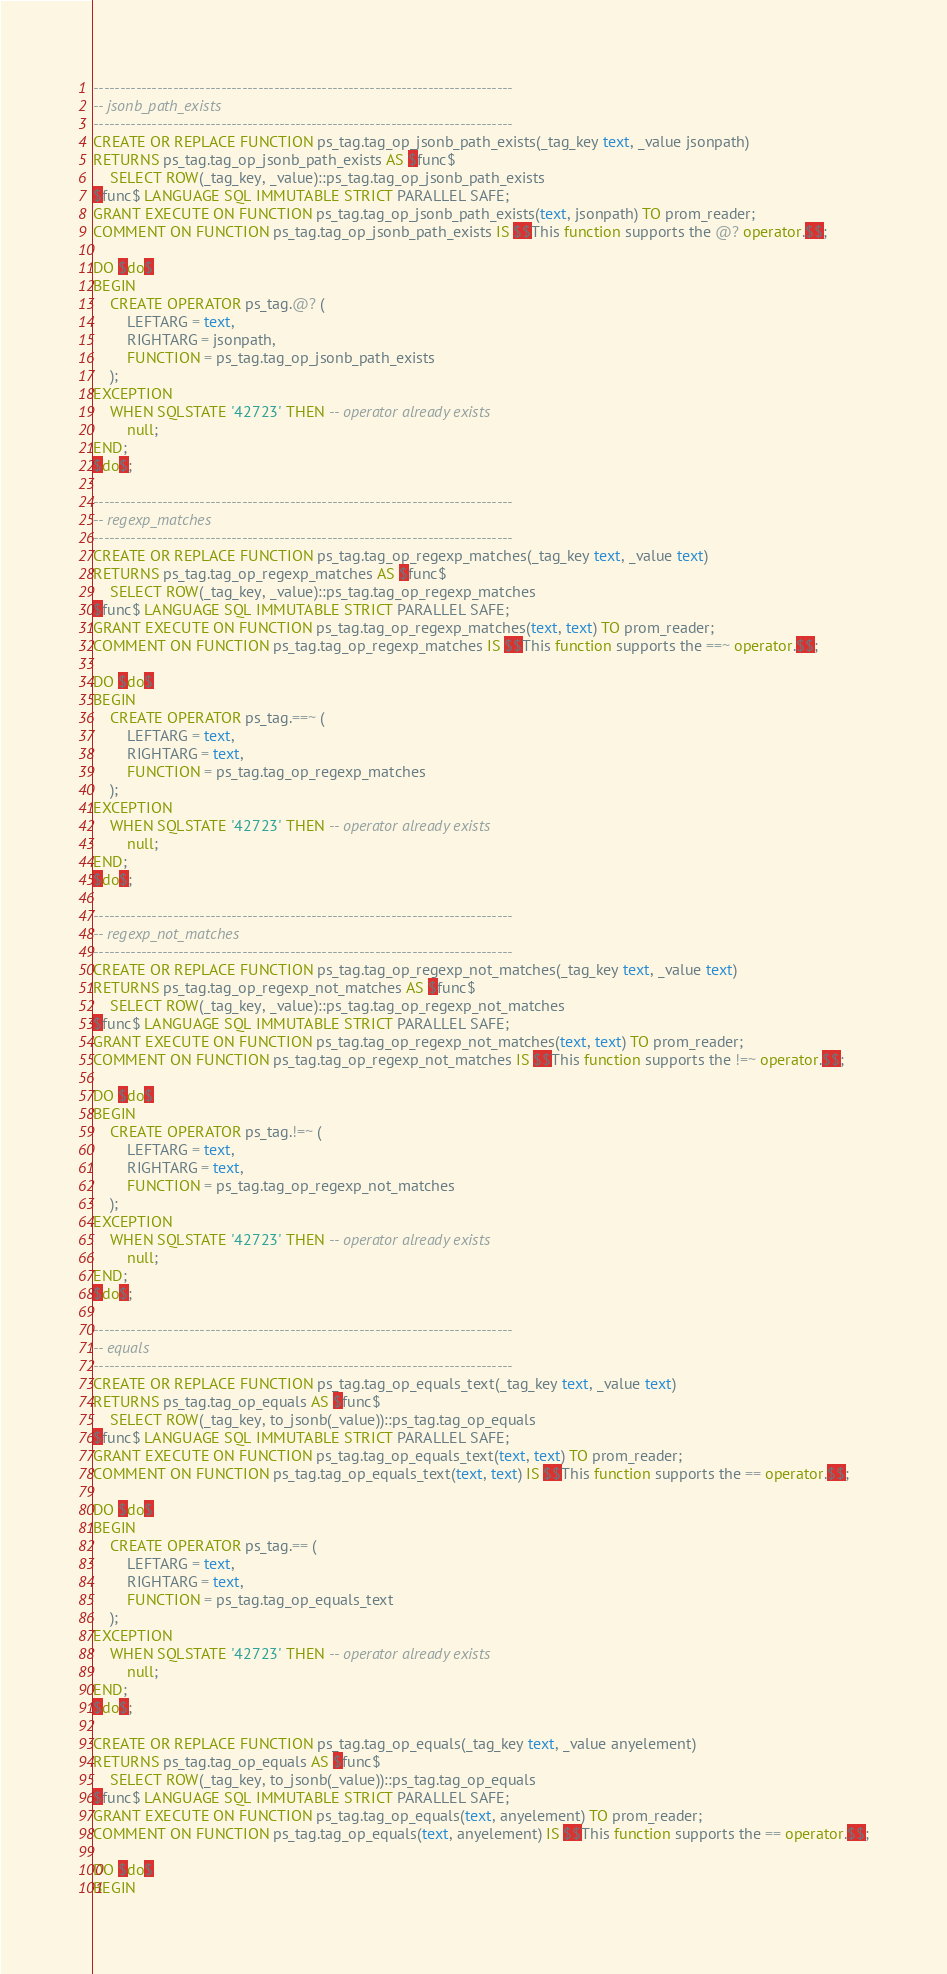Convert code to text. <code><loc_0><loc_0><loc_500><loc_500><_SQL_>-------------------------------------------------------------------------------
-- jsonb_path_exists
-------------------------------------------------------------------------------
CREATE OR REPLACE FUNCTION ps_tag.tag_op_jsonb_path_exists(_tag_key text, _value jsonpath)
RETURNS ps_tag.tag_op_jsonb_path_exists AS $func$
    SELECT ROW(_tag_key, _value)::ps_tag.tag_op_jsonb_path_exists
$func$ LANGUAGE SQL IMMUTABLE STRICT PARALLEL SAFE;
GRANT EXECUTE ON FUNCTION ps_tag.tag_op_jsonb_path_exists(text, jsonpath) TO prom_reader;
COMMENT ON FUNCTION ps_tag.tag_op_jsonb_path_exists IS $$This function supports the @? operator.$$;

DO $do$
BEGIN
    CREATE OPERATOR ps_tag.@? (
        LEFTARG = text,
        RIGHTARG = jsonpath,
        FUNCTION = ps_tag.tag_op_jsonb_path_exists
    );
EXCEPTION
    WHEN SQLSTATE '42723' THEN -- operator already exists
        null;
END;
$do$;

-------------------------------------------------------------------------------
-- regexp_matches
-------------------------------------------------------------------------------
CREATE OR REPLACE FUNCTION ps_tag.tag_op_regexp_matches(_tag_key text, _value text)
RETURNS ps_tag.tag_op_regexp_matches AS $func$
    SELECT ROW(_tag_key, _value)::ps_tag.tag_op_regexp_matches
$func$ LANGUAGE SQL IMMUTABLE STRICT PARALLEL SAFE;
GRANT EXECUTE ON FUNCTION ps_tag.tag_op_regexp_matches(text, text) TO prom_reader;
COMMENT ON FUNCTION ps_tag.tag_op_regexp_matches IS $$This function supports the ==~ operator.$$;

DO $do$
BEGIN
    CREATE OPERATOR ps_tag.==~ (
        LEFTARG = text,
        RIGHTARG = text,
        FUNCTION = ps_tag.tag_op_regexp_matches
    );
EXCEPTION
    WHEN SQLSTATE '42723' THEN -- operator already exists
        null;
END;
$do$;

-------------------------------------------------------------------------------
-- regexp_not_matches
-------------------------------------------------------------------------------
CREATE OR REPLACE FUNCTION ps_tag.tag_op_regexp_not_matches(_tag_key text, _value text)
RETURNS ps_tag.tag_op_regexp_not_matches AS $func$
    SELECT ROW(_tag_key, _value)::ps_tag.tag_op_regexp_not_matches
$func$ LANGUAGE SQL IMMUTABLE STRICT PARALLEL SAFE;
GRANT EXECUTE ON FUNCTION ps_tag.tag_op_regexp_not_matches(text, text) TO prom_reader;
COMMENT ON FUNCTION ps_tag.tag_op_regexp_not_matches IS $$This function supports the !=~ operator.$$;

DO $do$
BEGIN
    CREATE OPERATOR ps_tag.!=~ (
        LEFTARG = text,
        RIGHTARG = text,
        FUNCTION = ps_tag.tag_op_regexp_not_matches
    );
EXCEPTION
    WHEN SQLSTATE '42723' THEN -- operator already exists
        null;
END;
$do$;

-------------------------------------------------------------------------------
-- equals
-------------------------------------------------------------------------------
CREATE OR REPLACE FUNCTION ps_tag.tag_op_equals_text(_tag_key text, _value text)
RETURNS ps_tag.tag_op_equals AS $func$
    SELECT ROW(_tag_key, to_jsonb(_value))::ps_tag.tag_op_equals
$func$ LANGUAGE SQL IMMUTABLE STRICT PARALLEL SAFE;
GRANT EXECUTE ON FUNCTION ps_tag.tag_op_equals_text(text, text) TO prom_reader;
COMMENT ON FUNCTION ps_tag.tag_op_equals_text(text, text) IS $$This function supports the == operator.$$;

DO $do$
BEGIN
    CREATE OPERATOR ps_tag.== (
        LEFTARG = text,
        RIGHTARG = text,
        FUNCTION = ps_tag.tag_op_equals_text
    );
EXCEPTION
    WHEN SQLSTATE '42723' THEN -- operator already exists
        null;
END;
$do$;

CREATE OR REPLACE FUNCTION ps_tag.tag_op_equals(_tag_key text, _value anyelement)
RETURNS ps_tag.tag_op_equals AS $func$
    SELECT ROW(_tag_key, to_jsonb(_value))::ps_tag.tag_op_equals
$func$ LANGUAGE SQL IMMUTABLE STRICT PARALLEL SAFE;
GRANT EXECUTE ON FUNCTION ps_tag.tag_op_equals(text, anyelement) TO prom_reader;
COMMENT ON FUNCTION ps_tag.tag_op_equals(text, anyelement) IS $$This function supports the == operator.$$;

DO $do$
BEGIN</code> 